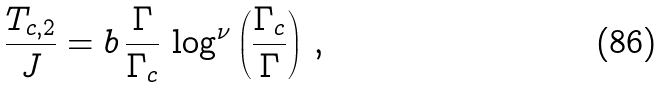Convert formula to latex. <formula><loc_0><loc_0><loc_500><loc_500>\frac { T _ { c , 2 } } { J } = b \, \frac { \Gamma } { \Gamma _ { c } } \, \log ^ { \nu } \left ( \frac { \Gamma _ { c } } { \Gamma } \right ) \, ,</formula> 